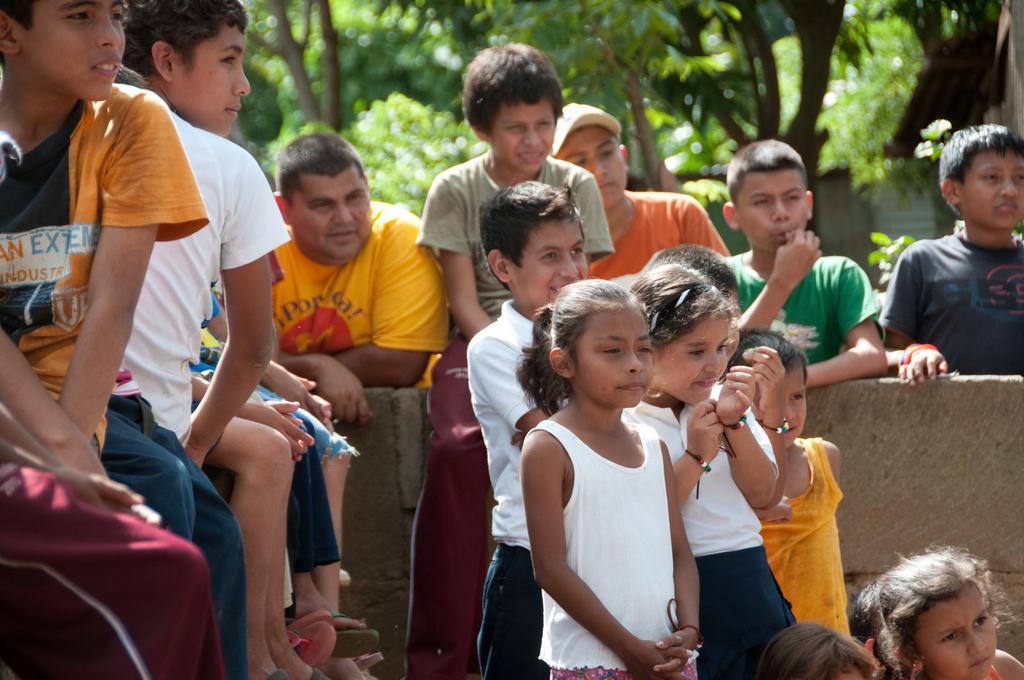Can you describe this image briefly? In this image there are groups of people, some people are sitting, some people are standing, there is a wall, there are treeś behind the person´s. 